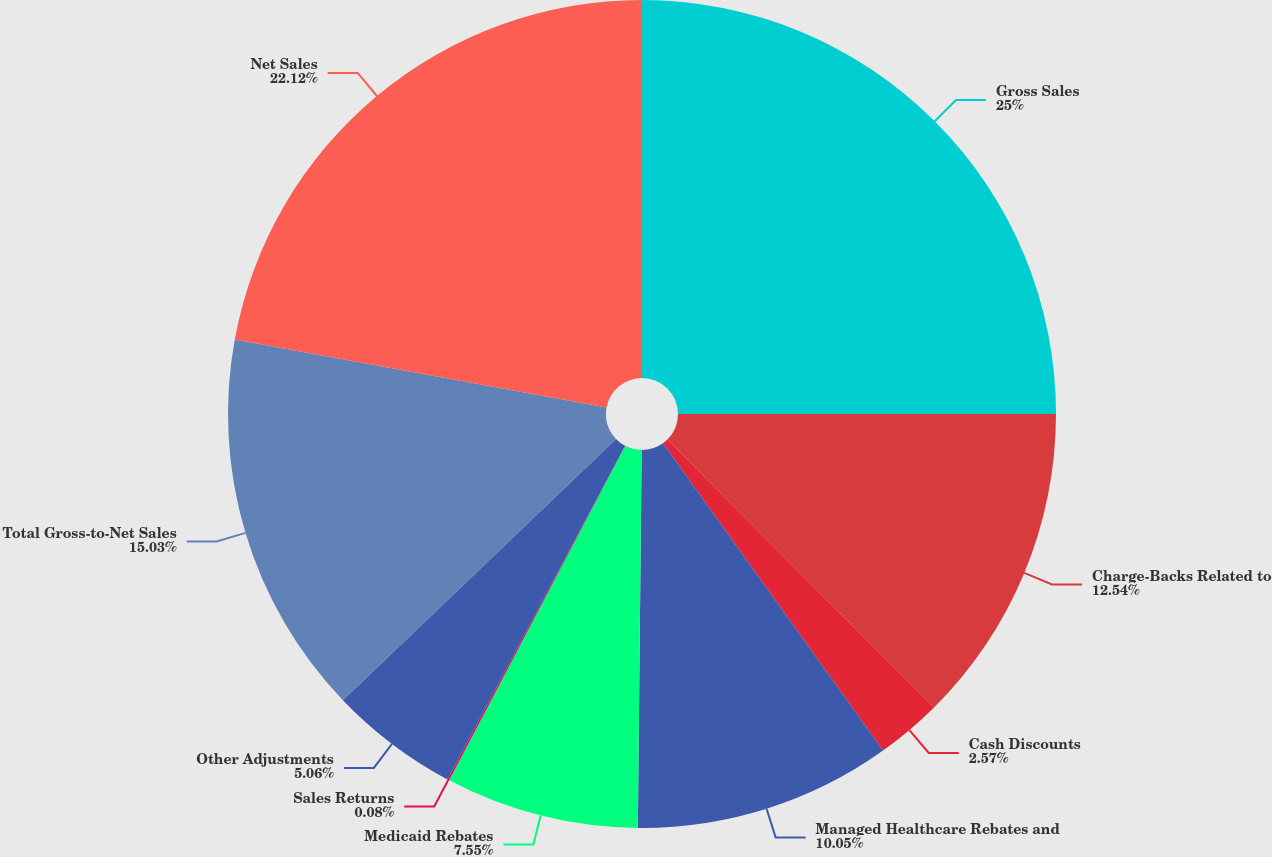Convert chart to OTSL. <chart><loc_0><loc_0><loc_500><loc_500><pie_chart><fcel>Gross Sales<fcel>Charge-Backs Related to<fcel>Cash Discounts<fcel>Managed Healthcare Rebates and<fcel>Medicaid Rebates<fcel>Sales Returns<fcel>Other Adjustments<fcel>Total Gross-to-Net Sales<fcel>Net Sales<nl><fcel>25.0%<fcel>12.54%<fcel>2.57%<fcel>10.05%<fcel>7.55%<fcel>0.08%<fcel>5.06%<fcel>15.03%<fcel>22.12%<nl></chart> 